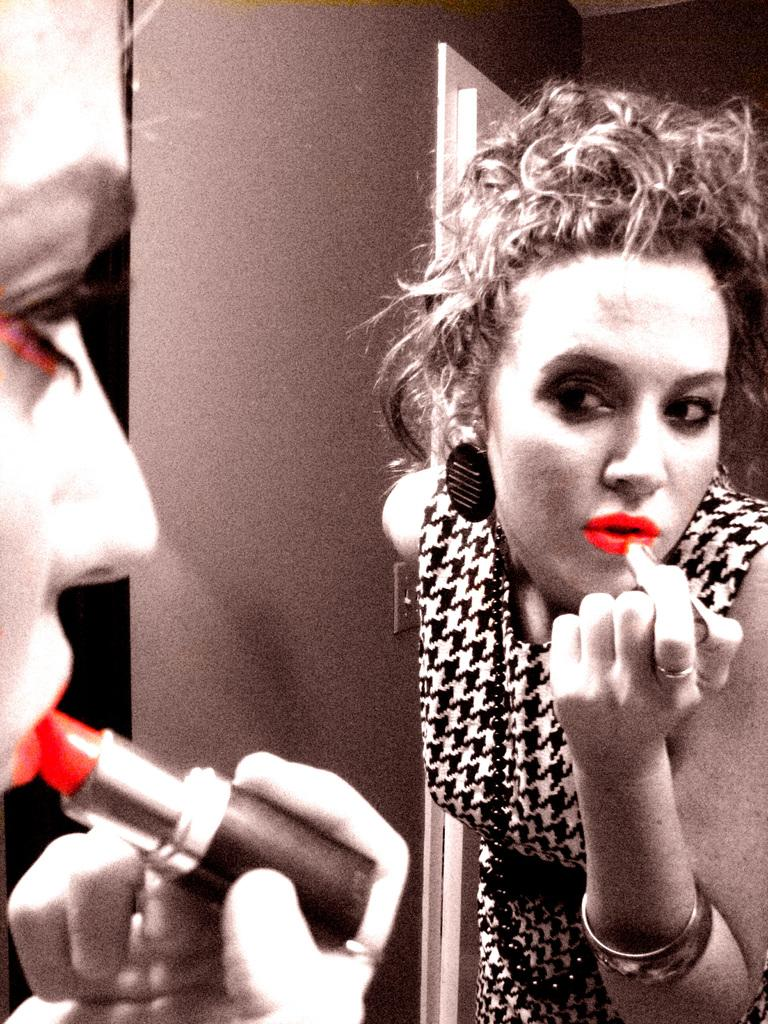What is present in the image? There is a person in the image. Can you describe the person's reflection in the image? The person's reflection is visible in the image. What is the person holding in the image? The person is holding a lipstick. What religion is the person practicing in the image? There is no indication of religion in the image; it only shows a person holding a lipstick and their reflection. 